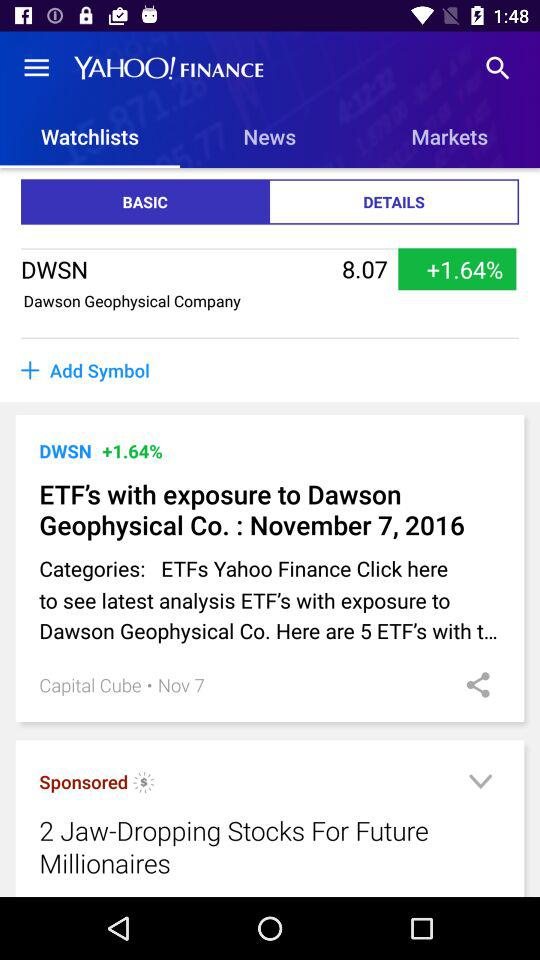When did "ETF's with exposure to Dawson Geophysical Co." happen? "ETF's with exposure to Dawson Geophysical Co." happened on November 7, 2016. 